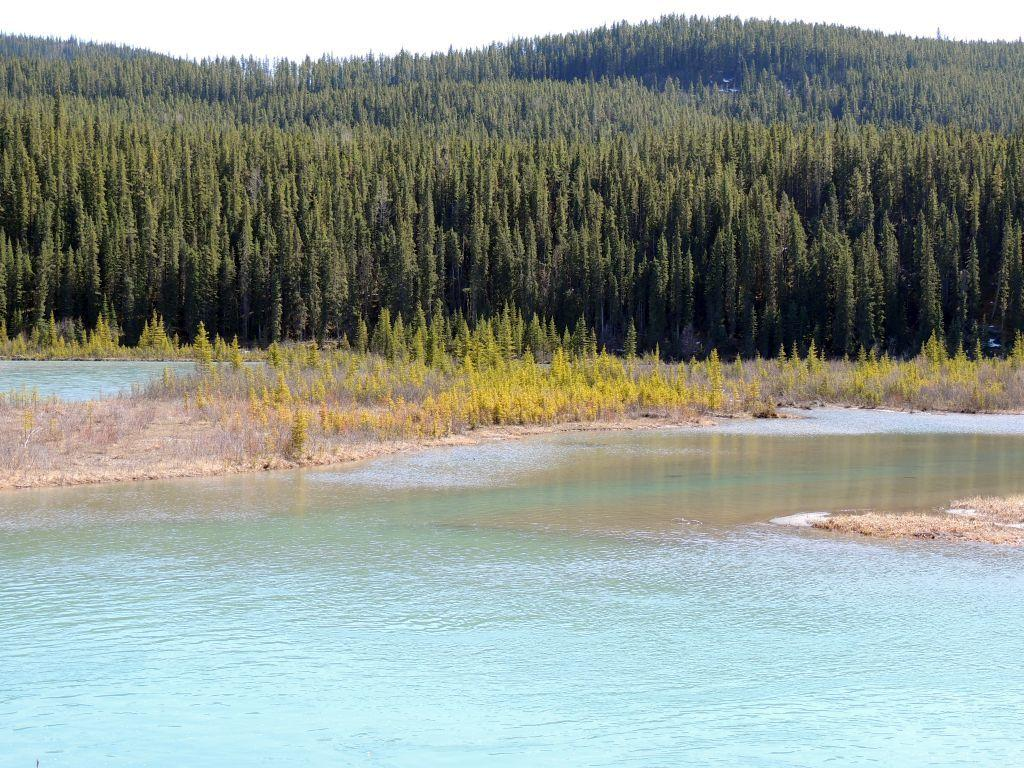What is the primary element visible in the image? There is water in the image. What types of vegetation can be seen in the image? There are plants and trees in the image. What can be seen in the background of the image? The sky is visible in the background of the image. What type of voice can be heard coming from the ocean in the image? There is no ocean or voice present in the image; it features water, plants, trees, and the sky. Is there a ball visible in the image? There is no ball present in the image. 